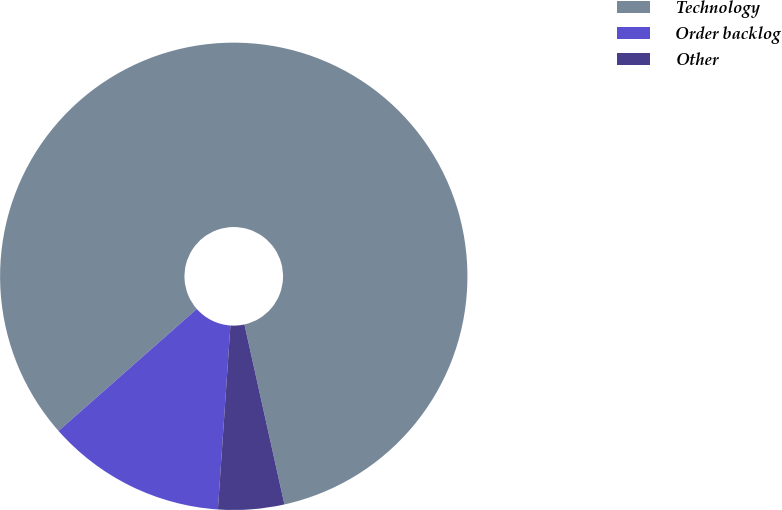<chart> <loc_0><loc_0><loc_500><loc_500><pie_chart><fcel>Technology<fcel>Order backlog<fcel>Other<nl><fcel>83.02%<fcel>12.41%<fcel>4.56%<nl></chart> 